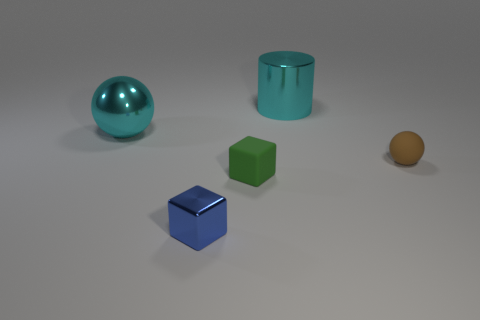There is a object that is the same color as the large sphere; what is it made of?
Provide a succinct answer. Metal. Is the material of the cyan thing on the right side of the small green matte block the same as the thing that is on the left side of the tiny blue metal cube?
Your response must be concise. Yes. There is a rubber object that is on the left side of the brown matte ball that is behind the shiny thing that is in front of the small green rubber block; what is its shape?
Your answer should be compact. Cube. There is a small blue object; what shape is it?
Offer a very short reply. Cube. The brown thing that is the same size as the blue metal object is what shape?
Give a very brief answer. Sphere. How many other things are there of the same color as the big shiny cylinder?
Make the answer very short. 1. Do the small green matte object left of the small rubber sphere and the cyan metallic thing that is on the left side of the cyan cylinder have the same shape?
Your answer should be compact. No. What number of objects are either big cyan metal things on the left side of the large cyan metallic cylinder or rubber things left of the matte sphere?
Your response must be concise. 2. How many other objects are there of the same material as the tiny green thing?
Your answer should be compact. 1. Are the ball on the right side of the blue metal cube and the big cyan cylinder made of the same material?
Provide a short and direct response. No. 